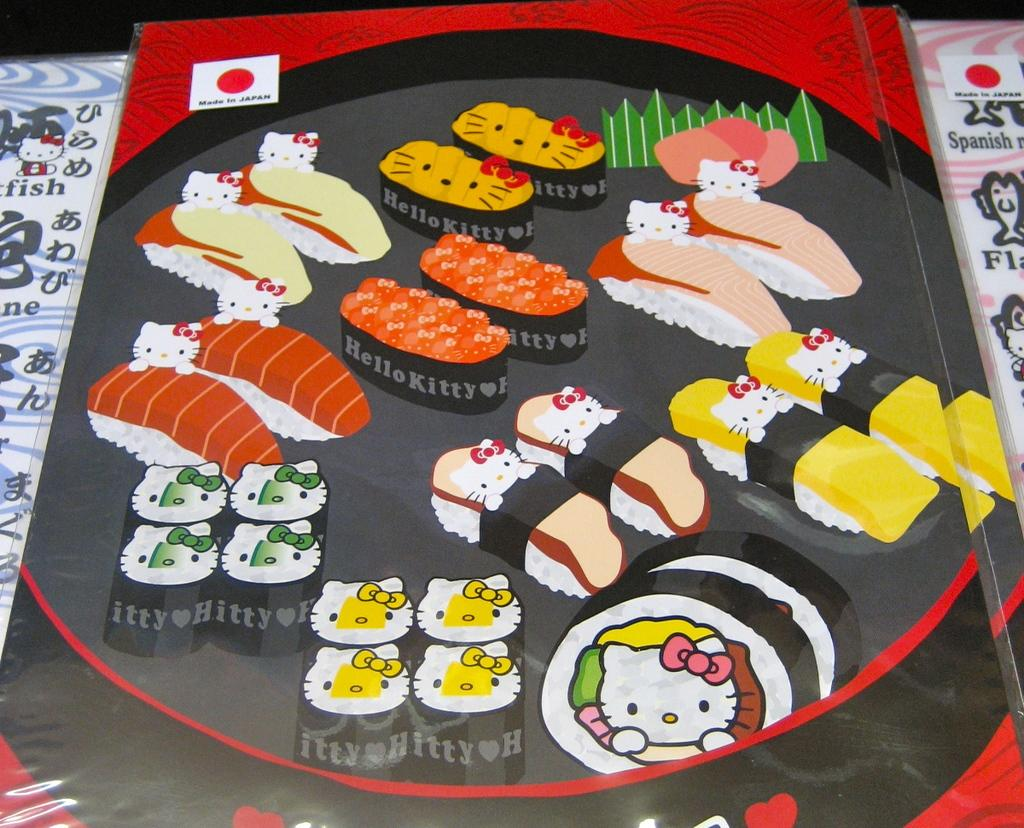What can be seen on the posters in the image? The posters contain images of food items. How many posters are visible in the image? The number of posters is not specified, but there are at least two posters with food images. What type of wax can be seen melting on the cart in the image? There is no cart or wax present in the image; it only features posters with food images. 